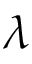Convert formula to latex. <formula><loc_0><loc_0><loc_500><loc_500>\lambda</formula> 